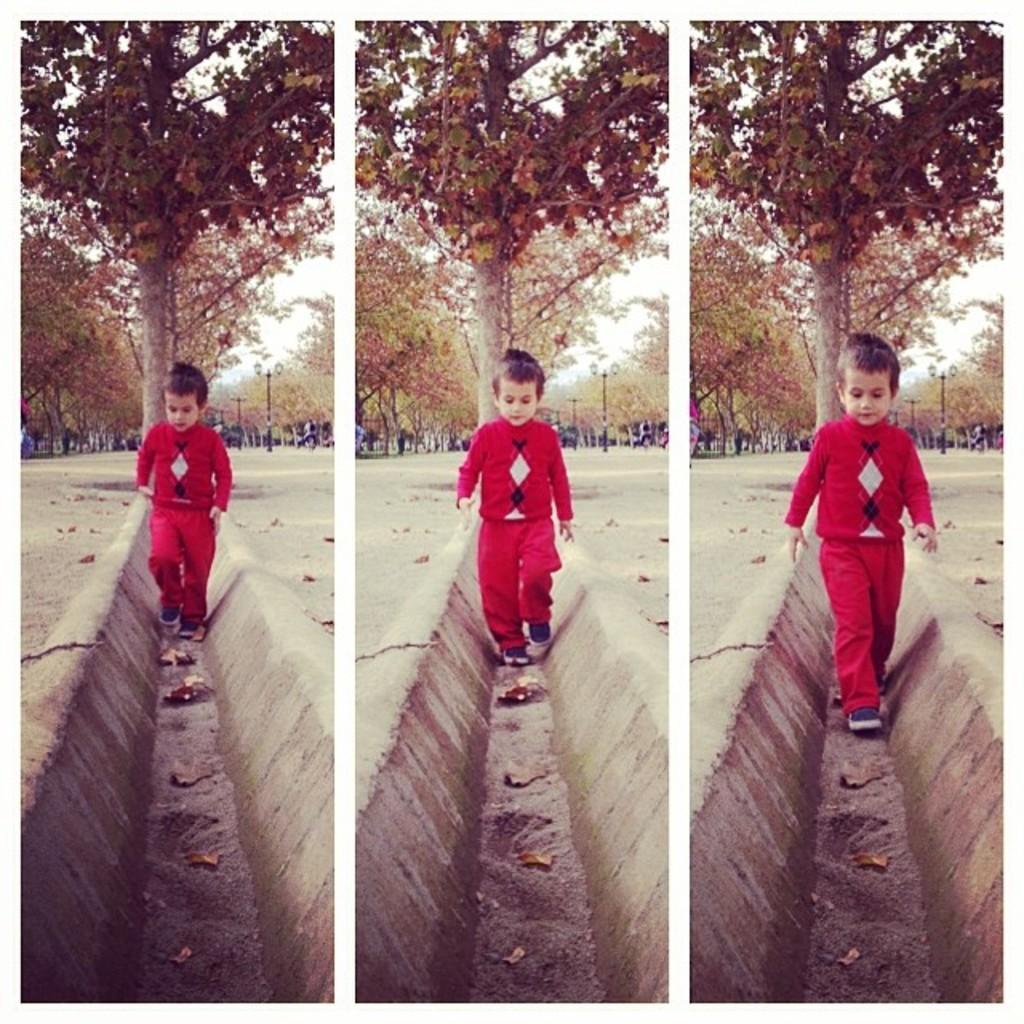Could you give a brief overview of what you see in this image? In this image there are colleges of three pictures in which there is a kid walking and in the background there are trees and persons and on the ground there are dry leaves. 